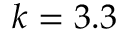Convert formula to latex. <formula><loc_0><loc_0><loc_500><loc_500>k = 3 . 3</formula> 